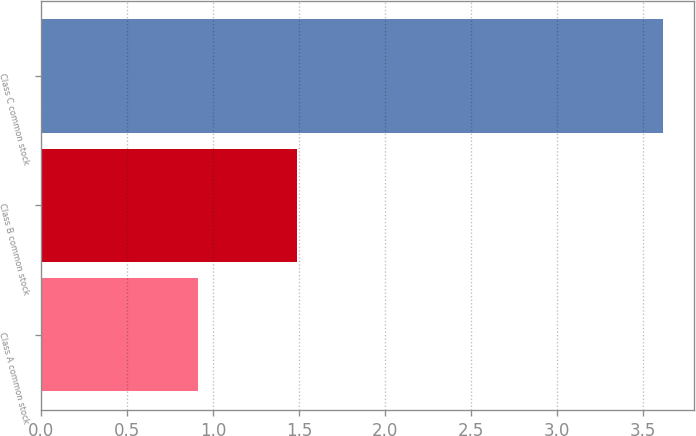<chart> <loc_0><loc_0><loc_500><loc_500><bar_chart><fcel>Class A common stock<fcel>Class B common stock<fcel>Class C common stock<nl><fcel>0.91<fcel>1.49<fcel>3.62<nl></chart> 